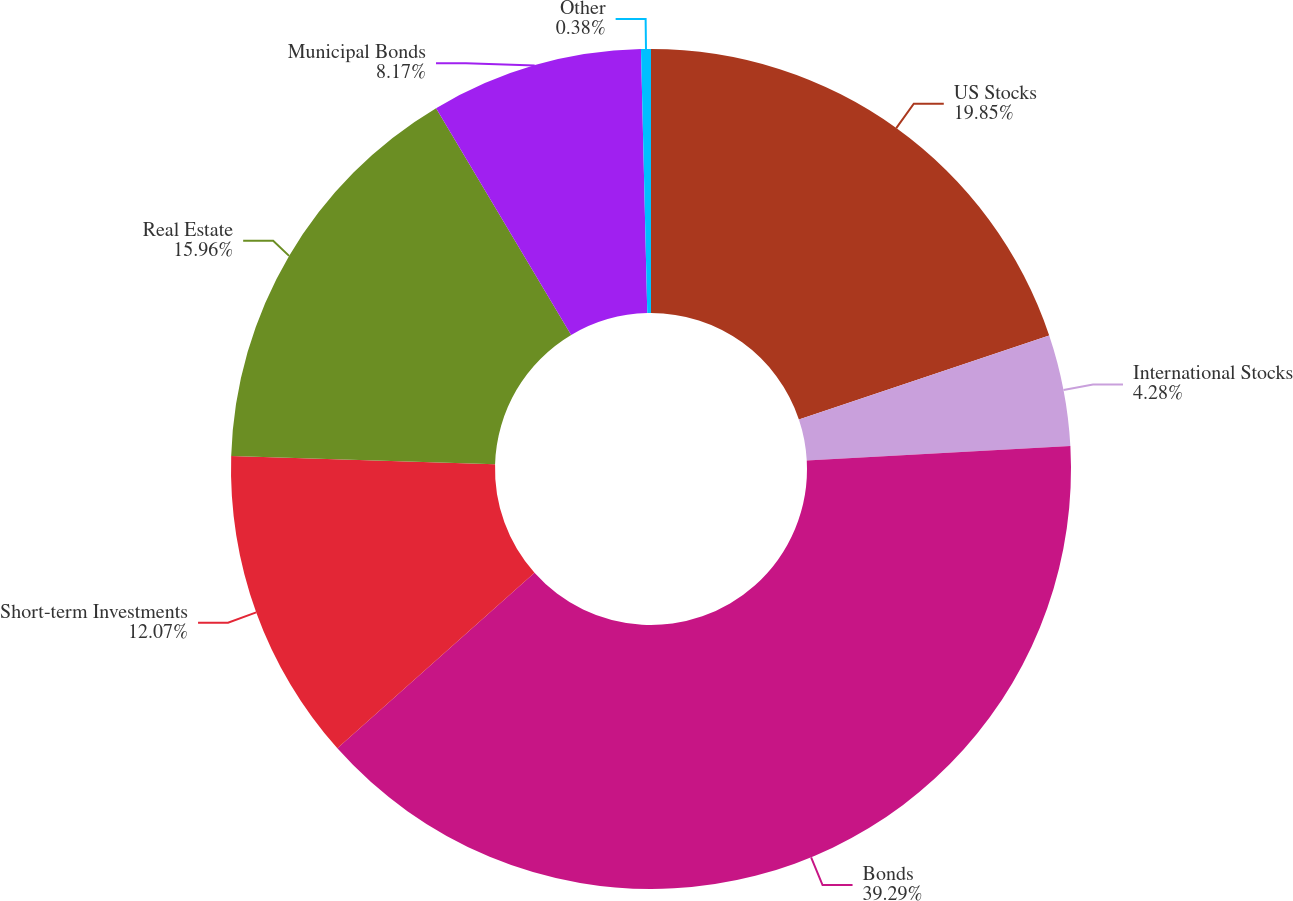<chart> <loc_0><loc_0><loc_500><loc_500><pie_chart><fcel>US Stocks<fcel>International Stocks<fcel>Bonds<fcel>Short-term Investments<fcel>Real Estate<fcel>Municipal Bonds<fcel>Other<nl><fcel>19.85%<fcel>4.28%<fcel>39.29%<fcel>12.07%<fcel>15.96%<fcel>8.17%<fcel>0.38%<nl></chart> 